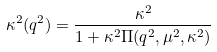<formula> <loc_0><loc_0><loc_500><loc_500>\kappa ^ { 2 } ( q ^ { 2 } ) = \frac { \kappa ^ { 2 } } { 1 + \kappa ^ { 2 } \Pi ( q ^ { 2 } , \mu ^ { 2 } , \kappa ^ { 2 } ) }</formula> 